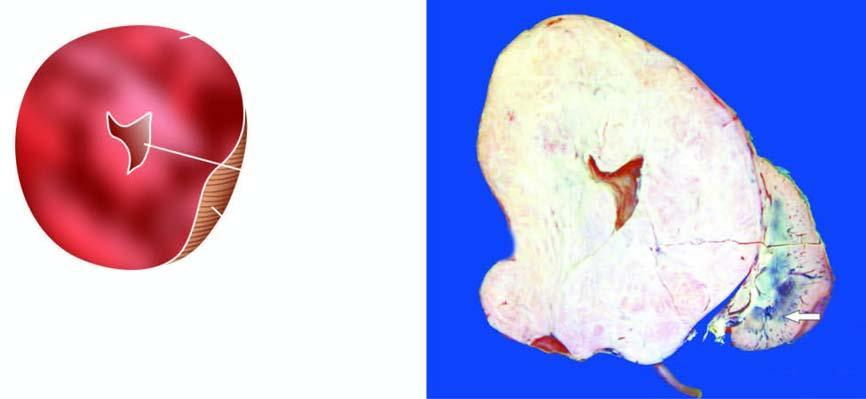how does the sectioned surface show replacement of almost whole kidney?
Answer the question using a single word or phrase. By the tumour leaving a thin strip of compressed renal tissue at lower end 